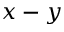<formula> <loc_0><loc_0><loc_500><loc_500>x - y</formula> 